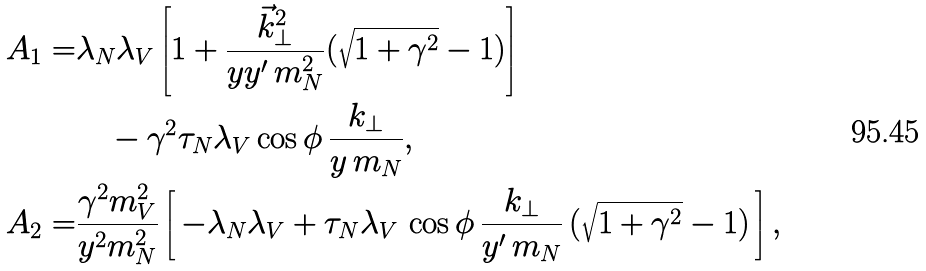Convert formula to latex. <formula><loc_0><loc_0><loc_500><loc_500>A _ { 1 } = & \lambda _ { N } \lambda _ { V } \left [ 1 + \frac { \vec { k } _ { \perp } ^ { 2 } } { y y ^ { \prime } \, m _ { N } ^ { 2 } } ( \sqrt { 1 + \gamma ^ { 2 } } - 1 ) \right ] \\ & \quad - \gamma ^ { 2 } \tau _ { N } \lambda _ { V } \cos \phi \, \frac { k _ { \perp } } { y \, m _ { N } } , \\ A _ { 2 } = & \frac { \gamma ^ { 2 } m _ { V } ^ { 2 } } { y ^ { 2 } m _ { N } ^ { 2 } } \left [ \, - \lambda _ { N } \lambda _ { V } + \tau _ { N } \lambda _ { V } \, \cos \phi \, \frac { k _ { \perp } } { y ^ { \prime } \, m _ { N } } \, ( \sqrt { 1 + \gamma ^ { 2 } } - 1 ) \, \right ] ,</formula> 